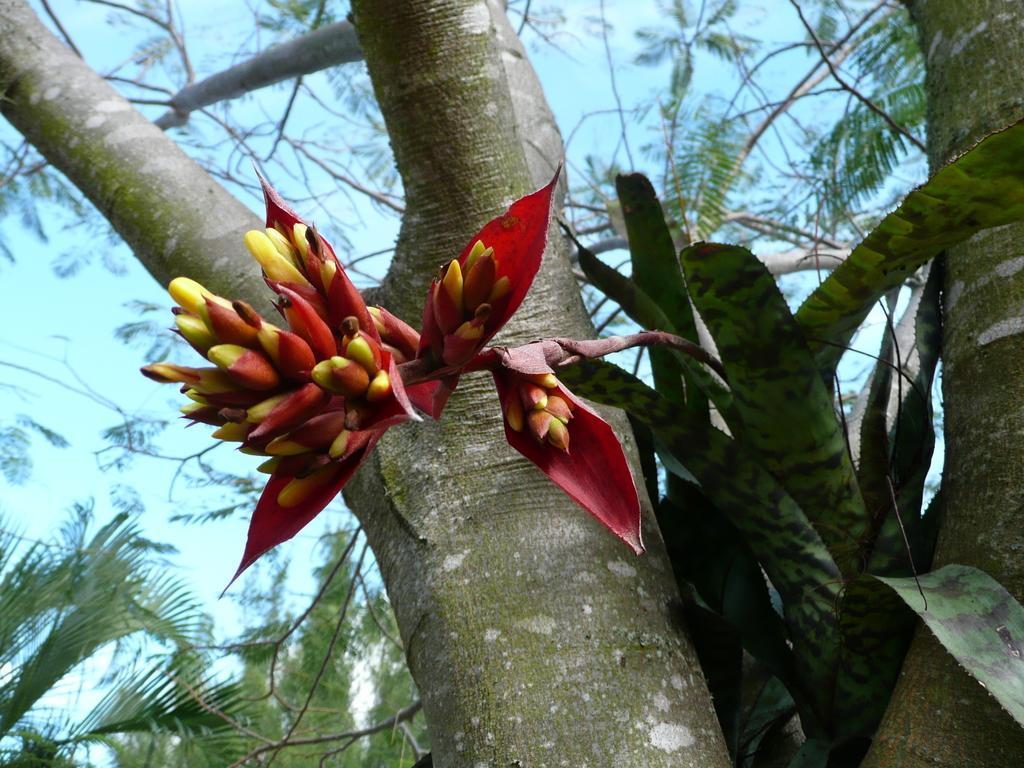Could you give a brief overview of what you see in this image? In the image we can see a tree and a plant. There is a flower of the plant, which is in yellow and red in color, and there is a pale blue sky. 